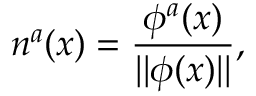Convert formula to latex. <formula><loc_0><loc_0><loc_500><loc_500>n ^ { a } ( x ) = \frac { \phi ^ { a } ( x ) } { | | \phi ( x ) | | } ,</formula> 